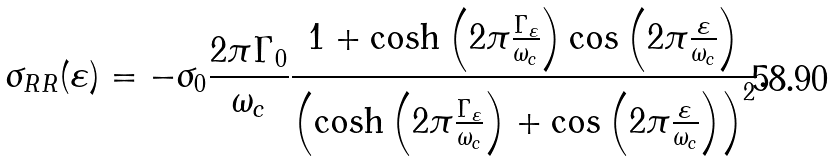Convert formula to latex. <formula><loc_0><loc_0><loc_500><loc_500>\sigma _ { R R } ( \varepsilon ) = - \sigma _ { 0 } \frac { 2 \pi \Gamma _ { 0 } } { \omega _ { c } } \frac { 1 + \cosh \left ( 2 \pi \frac { \Gamma _ { \varepsilon } } { \omega _ { c } } \right ) \cos \left ( 2 \pi \frac { \varepsilon } { \omega _ { c } } \right ) } { \left ( \cosh \left ( 2 \pi \frac { \Gamma _ { \varepsilon } } { \omega _ { c } } \right ) + \cos \left ( 2 \pi \frac { \varepsilon } { \omega _ { c } } \right ) \right ) ^ { 2 } } .</formula> 